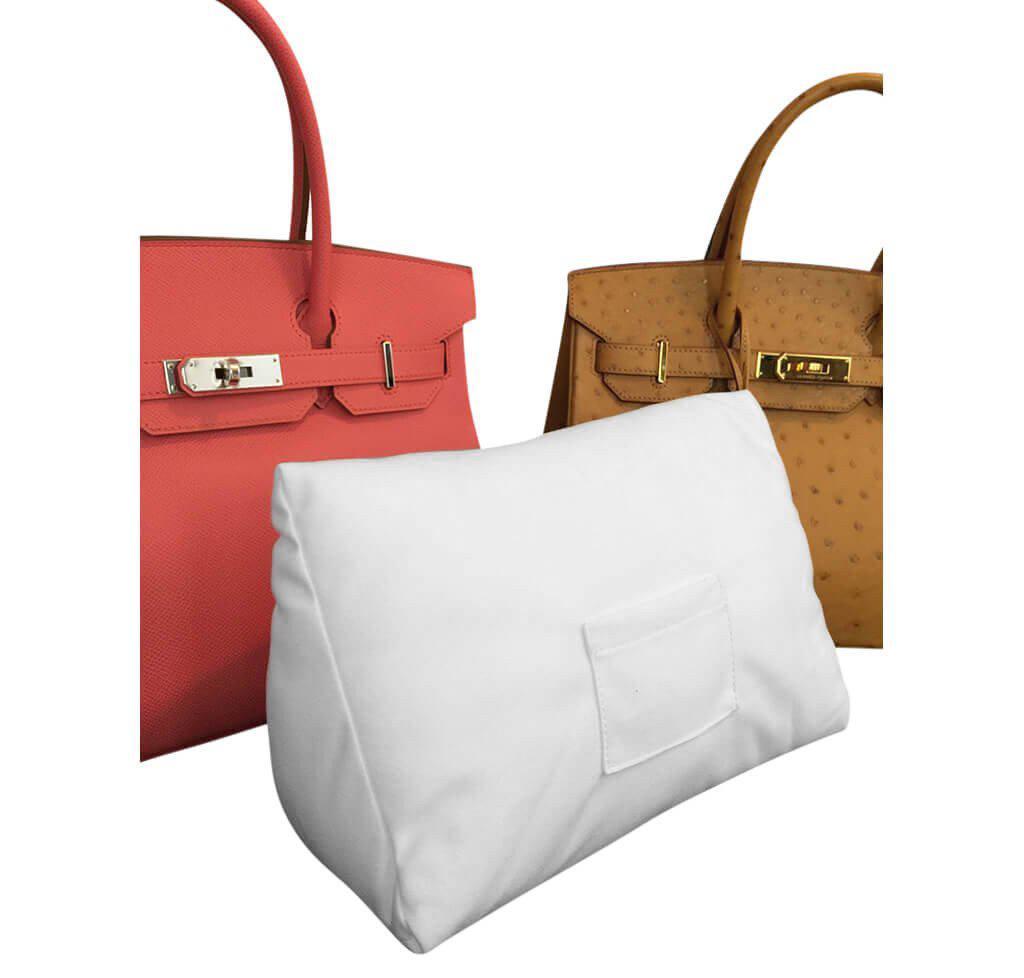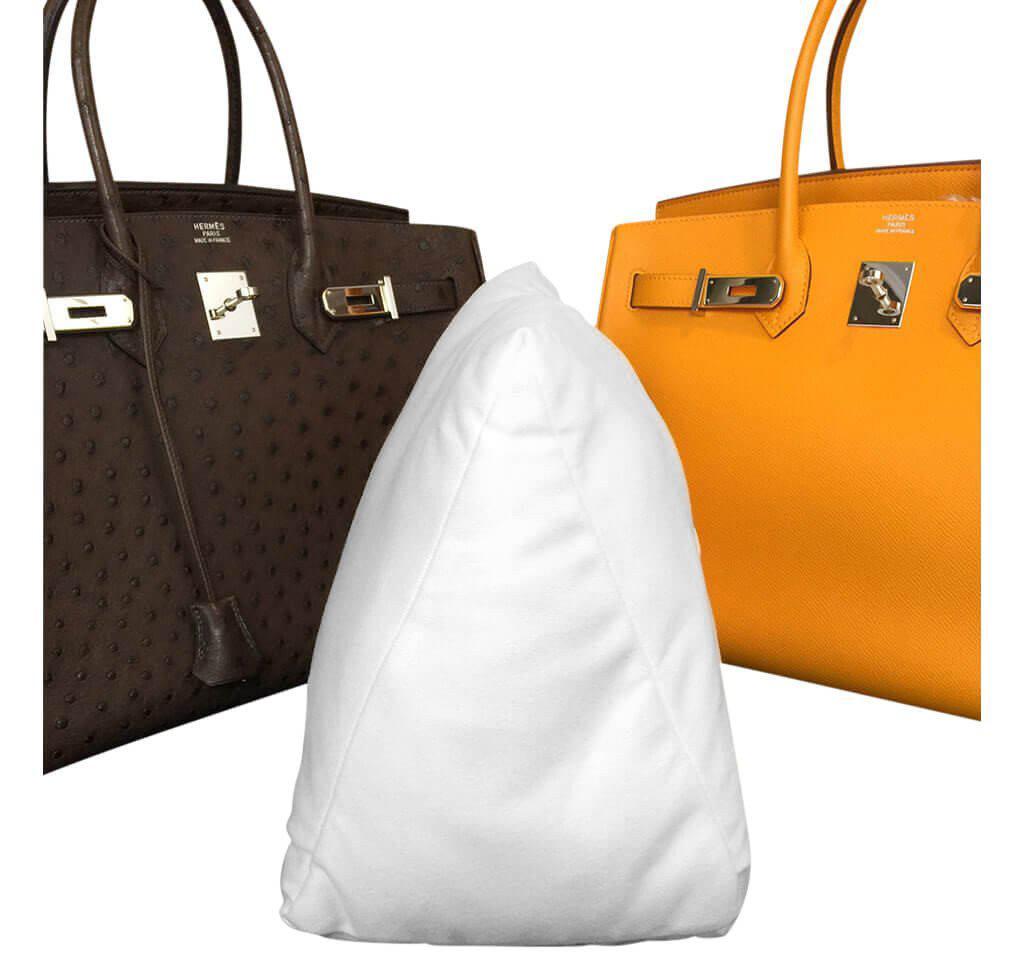The first image is the image on the left, the second image is the image on the right. For the images displayed, is the sentence "At least one image shows a dark brown bag and a golden-yellow bag behind a white pillow." factually correct? Answer yes or no. Yes. The first image is the image on the left, the second image is the image on the right. Evaluate the accuracy of this statement regarding the images: "Each image shows two different colored handbags with double handles and metal trim sitting behind a white stuffed pillow form.". Is it true? Answer yes or no. Yes. 